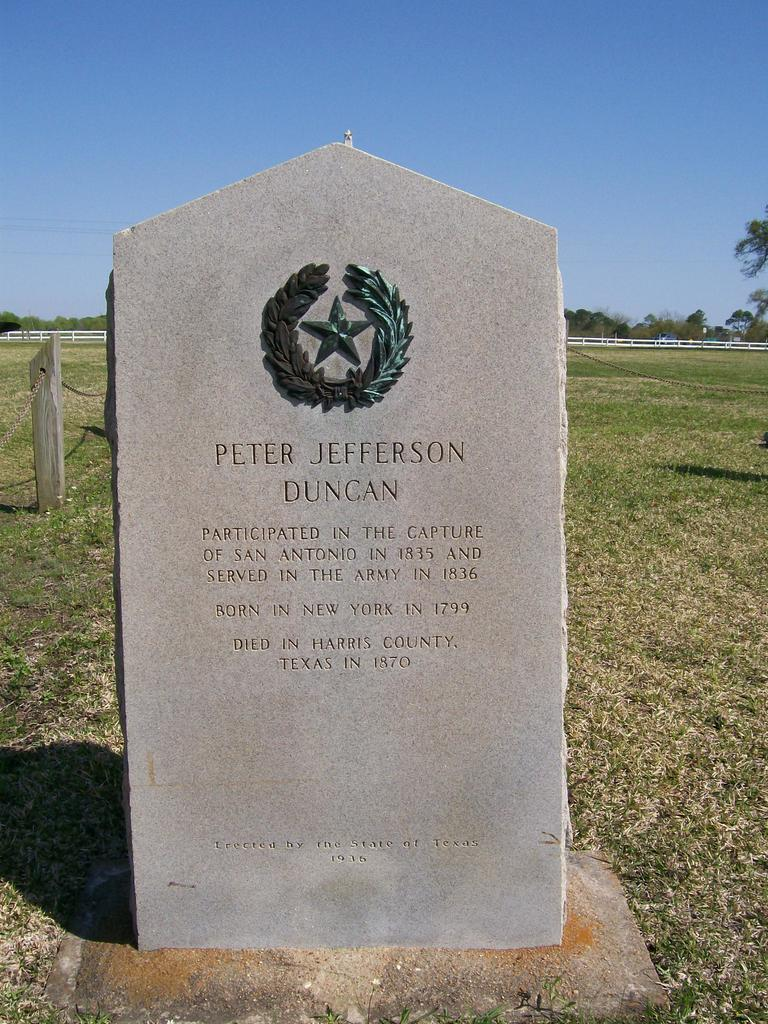What is the main subject of the picture? There is a gravestone in the picture. What type of ground is visible in the picture? There is grass on the floor in the picture. What can be seen in the background of the picture? There is a fence and trees in the backdrop of the picture. How is the sky depicted in the picture? The sky is clear in the picture. What type of frame is around the gravestone in the picture? There is no frame around the gravestone in the picture. Can you tell me how many aunts are mentioned in the image? There is no mention of an aunt in the image. 